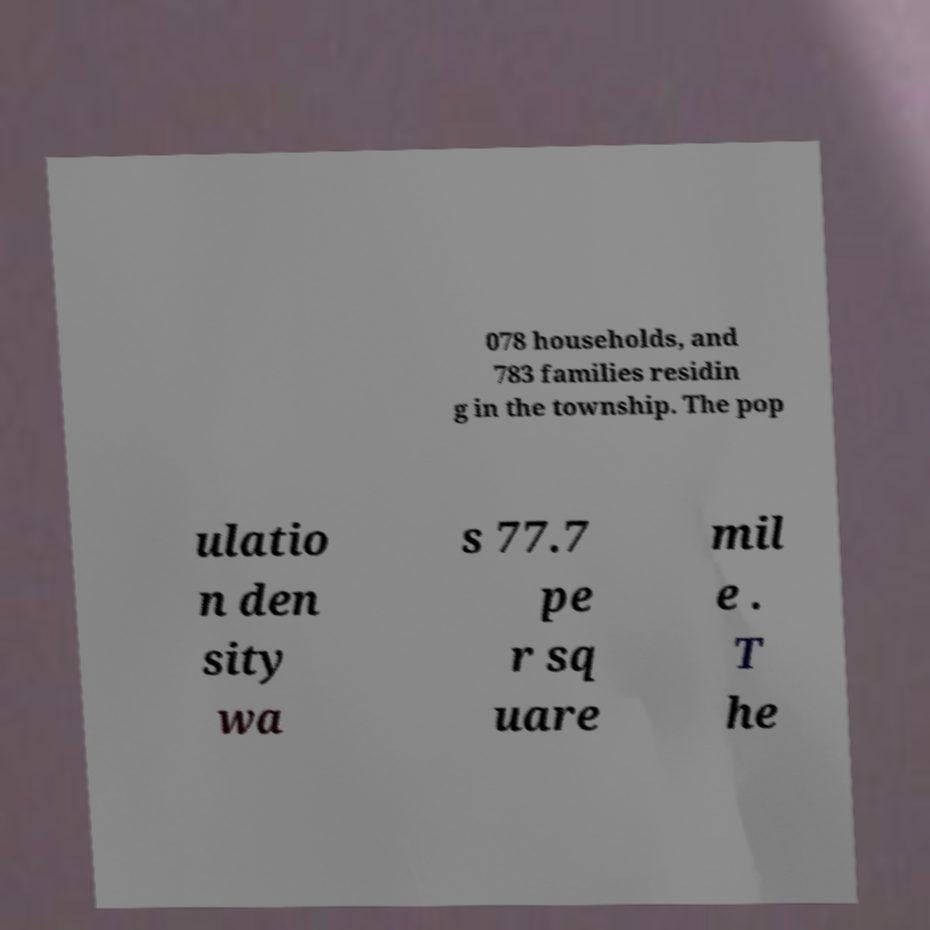Can you accurately transcribe the text from the provided image for me? 078 households, and 783 families residin g in the township. The pop ulatio n den sity wa s 77.7 pe r sq uare mil e . T he 